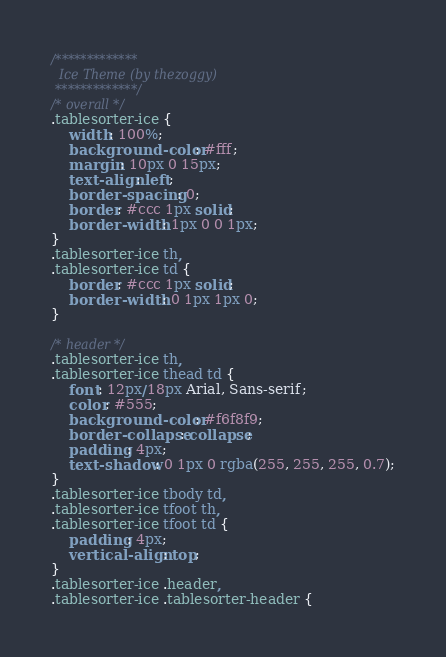Convert code to text. <code><loc_0><loc_0><loc_500><loc_500><_CSS_>/*************
  Ice Theme (by thezoggy)
 *************/
/* overall */
.tablesorter-ice {
	width: 100%;
	background-color: #fff;
	margin: 10px 0 15px;
	text-align: left;
	border-spacing: 0;
	border: #ccc 1px solid;
	border-width: 1px 0 0 1px;
}
.tablesorter-ice th,
.tablesorter-ice td {
	border: #ccc 1px solid;
	border-width: 0 1px 1px 0;
}

/* header */
.tablesorter-ice th,
.tablesorter-ice thead td {
	font: 12px/18px Arial, Sans-serif;
	color: #555;
	background-color: #f6f8f9;
	border-collapse: collapse;
	padding: 4px;
	text-shadow: 0 1px 0 rgba(255, 255, 255, 0.7);
}
.tablesorter-ice tbody td,
.tablesorter-ice tfoot th,
.tablesorter-ice tfoot td {
	padding: 4px;
	vertical-align: top;
}
.tablesorter-ice .header,
.tablesorter-ice .tablesorter-header {</code> 